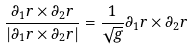Convert formula to latex. <formula><loc_0><loc_0><loc_500><loc_500>\frac { \partial _ { 1 } r \times \partial _ { 2 } r } { | \partial _ { 1 } r \times \partial _ { 2 } r | } = \frac { 1 } { \sqrt { g } } \partial _ { 1 } r \times \partial _ { 2 } r</formula> 